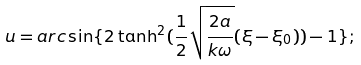Convert formula to latex. <formula><loc_0><loc_0><loc_500><loc_500>u = a r c \sin \{ 2 \tanh ^ { 2 } ( \frac { 1 } { 2 } \sqrt { \frac { 2 a } { k \omega } } ( \xi - { \xi } _ { 0 } ) ) - 1 \} ;</formula> 